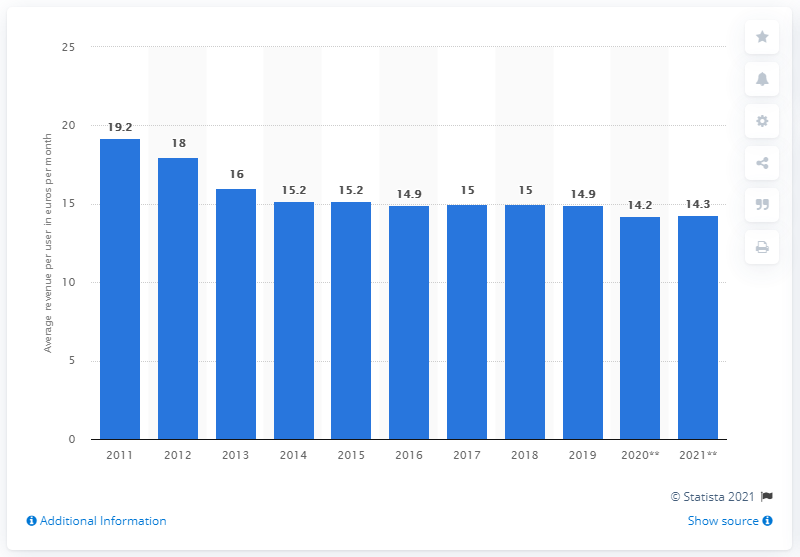What might be the causes for the decrease in average revenue per user in the later years? There are several potential factors that could have contributed to the decrease in ARPU for mobile broadband customers in Europe. These may include increased competition leading to lower pricing, regulatory changes, the introduction of more cost-effective technology, and the overall maturation of the market. Additionally, as mobile broadband usage becomes more widespread, data plans are likely to become more affordable to attract and retain customers. 